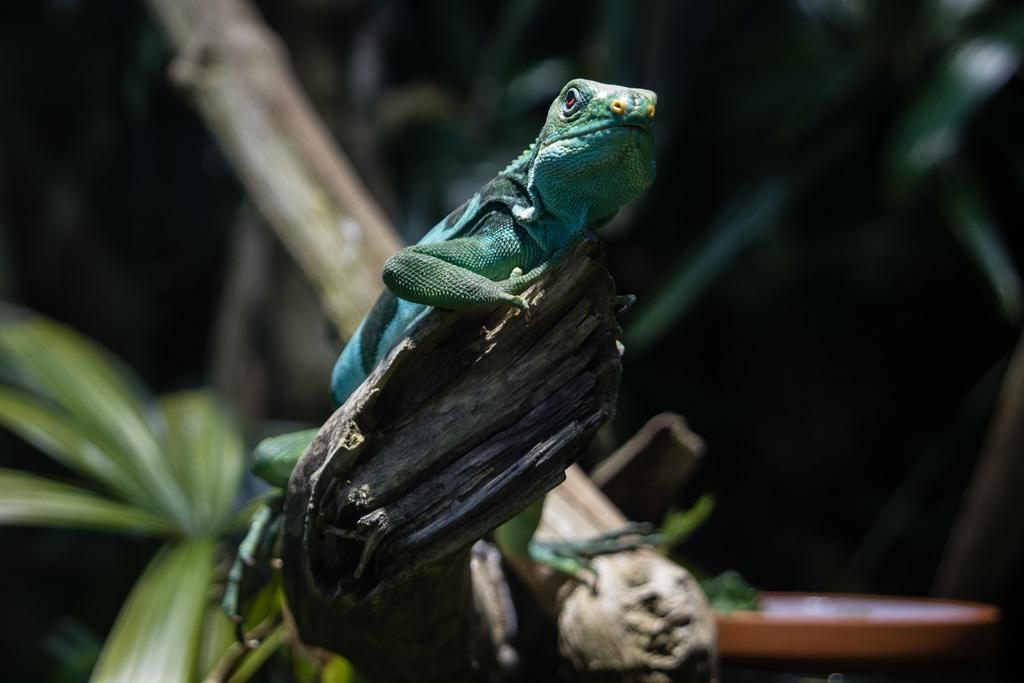How would you summarize this image in a sentence or two? In the center of the image, we can see a garden lizard on the branch and in the background, there are leaves and we can see a flower pot. 